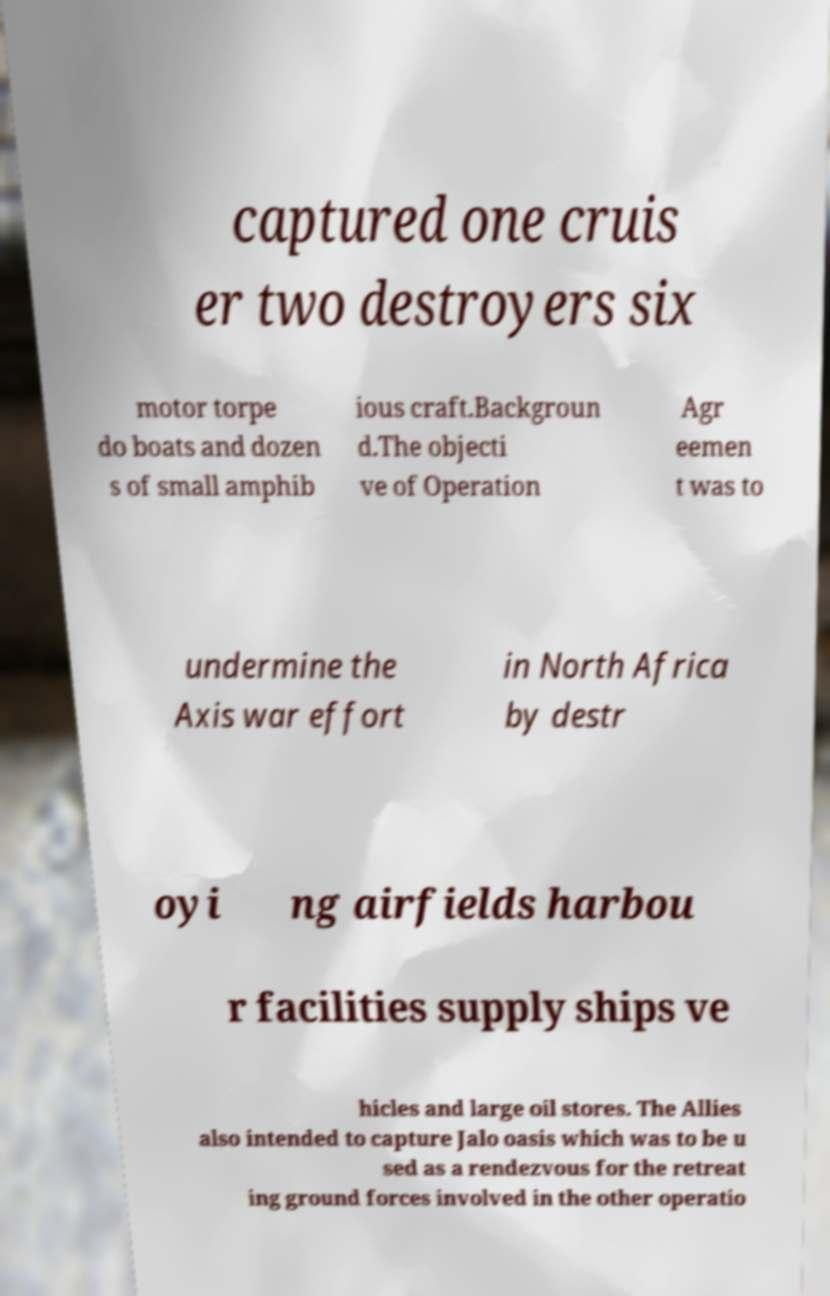For documentation purposes, I need the text within this image transcribed. Could you provide that? captured one cruis er two destroyers six motor torpe do boats and dozen s of small amphib ious craft.Backgroun d.The objecti ve of Operation Agr eemen t was to undermine the Axis war effort in North Africa by destr oyi ng airfields harbou r facilities supply ships ve hicles and large oil stores. The Allies also intended to capture Jalo oasis which was to be u sed as a rendezvous for the retreat ing ground forces involved in the other operatio 